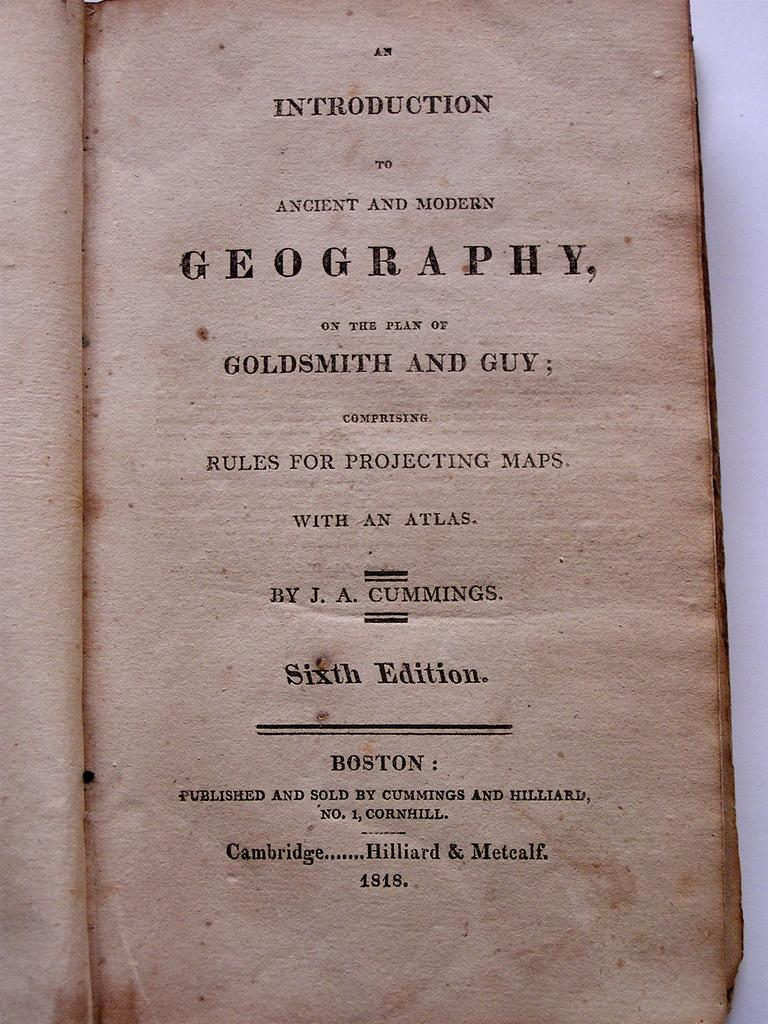Provide a one-sentence caption for the provided image. An old geography book with maps and an atlas is open to the main page on the table. 